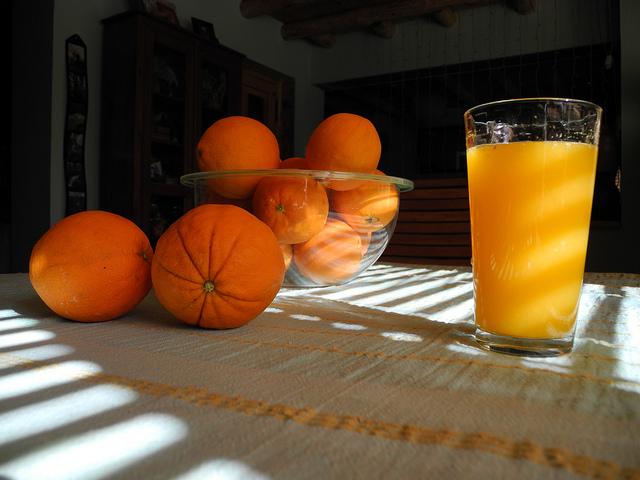How many oranges that are not in the bowl?
Write a very short answer. 2. Are the juice and the fruit related?
Short answer required. Yes. What fruit is in the bowl?
Give a very brief answer. Oranges. 